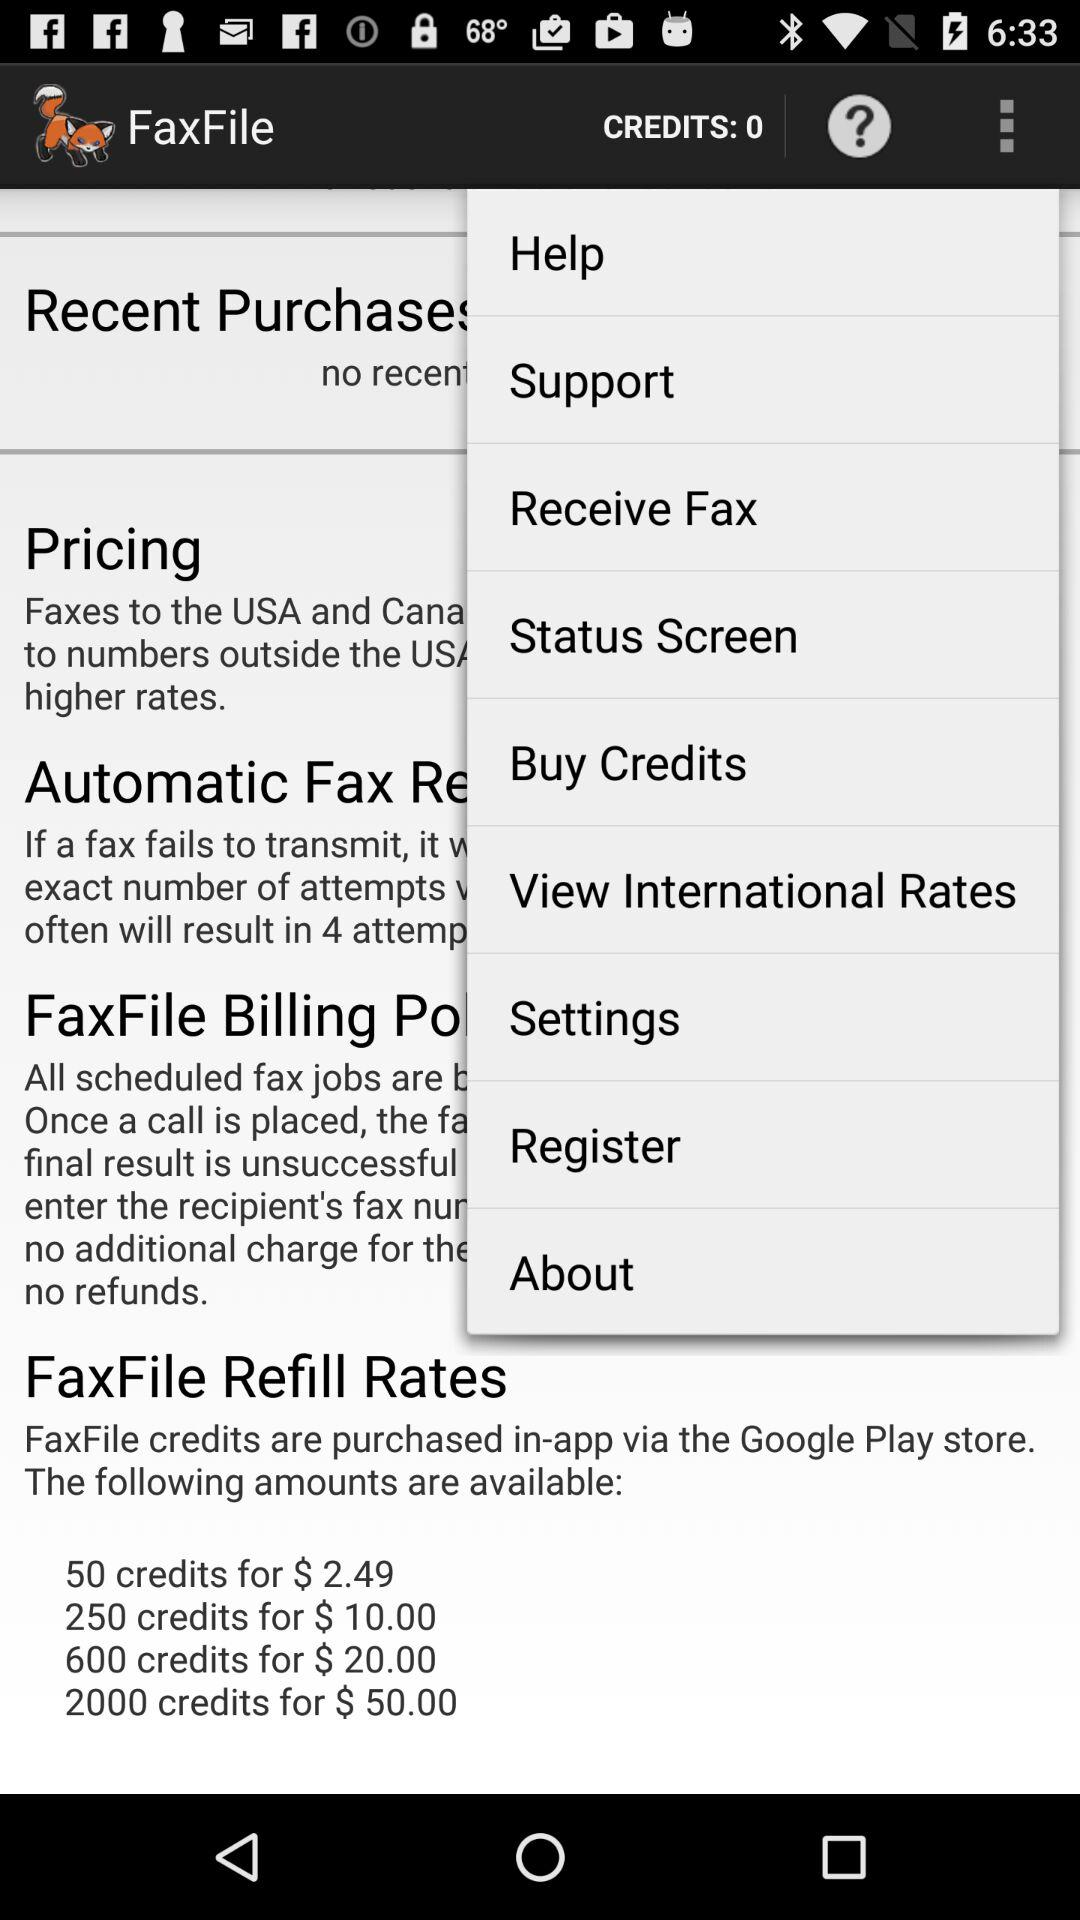What is the price for 50 credits? The price for 50 credits is $2.49. 